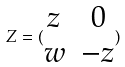Convert formula to latex. <formula><loc_0><loc_0><loc_500><loc_500>Z = ( \begin{matrix} z & 0 \\ w & - z \end{matrix} )</formula> 